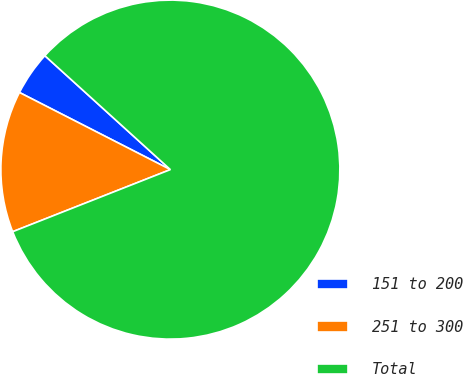<chart> <loc_0><loc_0><loc_500><loc_500><pie_chart><fcel>151 to 200<fcel>251 to 300<fcel>Total<nl><fcel>4.21%<fcel>13.49%<fcel>82.3%<nl></chart> 